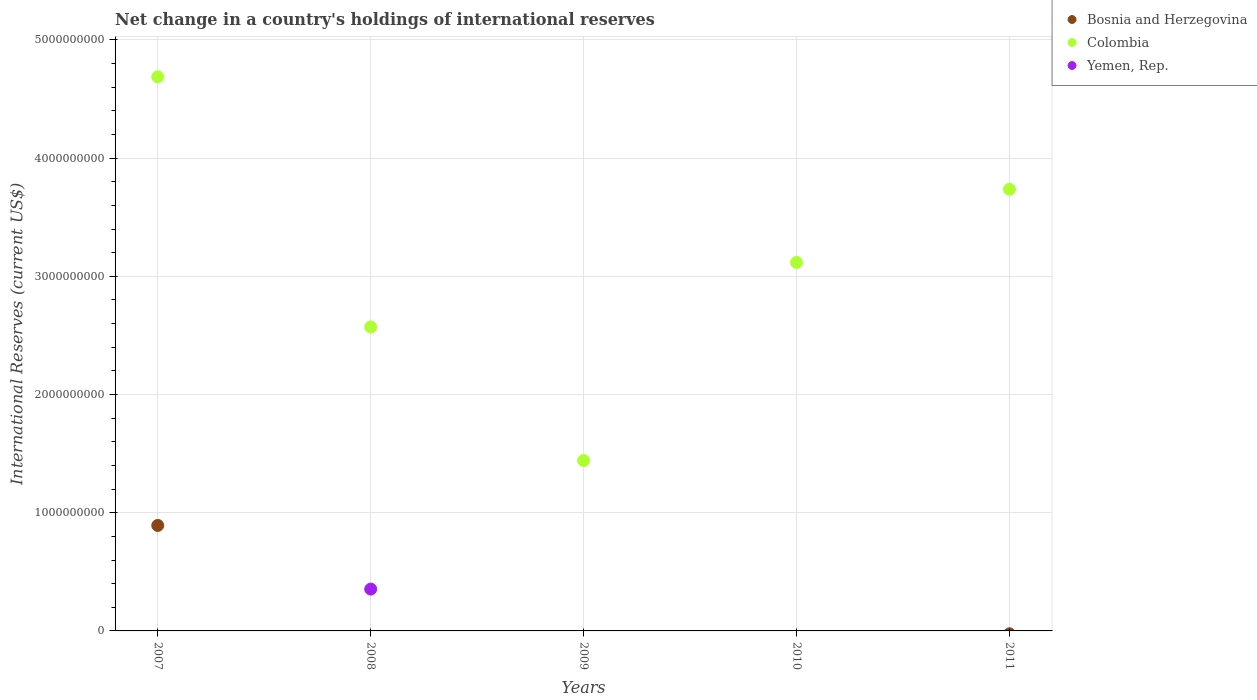What is the international reserves in Bosnia and Herzegovina in 2008?
Offer a terse response. 0. Across all years, what is the maximum international reserves in Yemen, Rep.?
Give a very brief answer. 3.54e+08. Across all years, what is the minimum international reserves in Colombia?
Provide a short and direct response. 1.44e+09. What is the total international reserves in Bosnia and Herzegovina in the graph?
Provide a short and direct response. 8.92e+08. What is the difference between the international reserves in Colombia in 2007 and that in 2011?
Your response must be concise. 9.51e+08. What is the average international reserves in Colombia per year?
Your answer should be compact. 3.11e+09. In the year 2007, what is the difference between the international reserves in Bosnia and Herzegovina and international reserves in Colombia?
Your answer should be very brief. -3.80e+09. What is the ratio of the international reserves in Colombia in 2009 to that in 2011?
Ensure brevity in your answer.  0.39. Is the international reserves in Colombia in 2007 less than that in 2011?
Provide a succinct answer. No. What is the difference between the highest and the second highest international reserves in Colombia?
Provide a short and direct response. 9.51e+08. What is the difference between the highest and the lowest international reserves in Colombia?
Your response must be concise. 3.25e+09. Is the international reserves in Yemen, Rep. strictly greater than the international reserves in Bosnia and Herzegovina over the years?
Make the answer very short. No. Is the international reserves in Bosnia and Herzegovina strictly less than the international reserves in Yemen, Rep. over the years?
Give a very brief answer. No. How many dotlines are there?
Offer a very short reply. 3. How many years are there in the graph?
Ensure brevity in your answer.  5. Are the values on the major ticks of Y-axis written in scientific E-notation?
Your answer should be very brief. No. Does the graph contain any zero values?
Offer a terse response. Yes. What is the title of the graph?
Provide a short and direct response. Net change in a country's holdings of international reserves. Does "Cabo Verde" appear as one of the legend labels in the graph?
Make the answer very short. No. What is the label or title of the Y-axis?
Ensure brevity in your answer.  International Reserves (current US$). What is the International Reserves (current US$) of Bosnia and Herzegovina in 2007?
Provide a succinct answer. 8.92e+08. What is the International Reserves (current US$) of Colombia in 2007?
Ensure brevity in your answer.  4.69e+09. What is the International Reserves (current US$) of Bosnia and Herzegovina in 2008?
Offer a very short reply. 0. What is the International Reserves (current US$) of Colombia in 2008?
Offer a terse response. 2.57e+09. What is the International Reserves (current US$) in Yemen, Rep. in 2008?
Your answer should be compact. 3.54e+08. What is the International Reserves (current US$) of Colombia in 2009?
Give a very brief answer. 1.44e+09. What is the International Reserves (current US$) of Bosnia and Herzegovina in 2010?
Make the answer very short. 0. What is the International Reserves (current US$) of Colombia in 2010?
Ensure brevity in your answer.  3.12e+09. What is the International Reserves (current US$) of Yemen, Rep. in 2010?
Make the answer very short. 0. What is the International Reserves (current US$) in Bosnia and Herzegovina in 2011?
Your answer should be very brief. 0. What is the International Reserves (current US$) of Colombia in 2011?
Your response must be concise. 3.74e+09. Across all years, what is the maximum International Reserves (current US$) in Bosnia and Herzegovina?
Your response must be concise. 8.92e+08. Across all years, what is the maximum International Reserves (current US$) of Colombia?
Your response must be concise. 4.69e+09. Across all years, what is the maximum International Reserves (current US$) of Yemen, Rep.?
Your answer should be compact. 3.54e+08. Across all years, what is the minimum International Reserves (current US$) in Colombia?
Your answer should be very brief. 1.44e+09. What is the total International Reserves (current US$) in Bosnia and Herzegovina in the graph?
Offer a terse response. 8.92e+08. What is the total International Reserves (current US$) in Colombia in the graph?
Keep it short and to the point. 1.56e+1. What is the total International Reserves (current US$) of Yemen, Rep. in the graph?
Offer a terse response. 3.54e+08. What is the difference between the International Reserves (current US$) in Colombia in 2007 and that in 2008?
Keep it short and to the point. 2.12e+09. What is the difference between the International Reserves (current US$) in Colombia in 2007 and that in 2009?
Provide a succinct answer. 3.25e+09. What is the difference between the International Reserves (current US$) of Colombia in 2007 and that in 2010?
Keep it short and to the point. 1.57e+09. What is the difference between the International Reserves (current US$) in Colombia in 2007 and that in 2011?
Offer a very short reply. 9.51e+08. What is the difference between the International Reserves (current US$) of Colombia in 2008 and that in 2009?
Provide a succinct answer. 1.13e+09. What is the difference between the International Reserves (current US$) in Colombia in 2008 and that in 2010?
Your answer should be very brief. -5.46e+08. What is the difference between the International Reserves (current US$) of Colombia in 2008 and that in 2011?
Your response must be concise. -1.17e+09. What is the difference between the International Reserves (current US$) in Colombia in 2009 and that in 2010?
Make the answer very short. -1.68e+09. What is the difference between the International Reserves (current US$) of Colombia in 2009 and that in 2011?
Make the answer very short. -2.30e+09. What is the difference between the International Reserves (current US$) in Colombia in 2010 and that in 2011?
Give a very brief answer. -6.19e+08. What is the difference between the International Reserves (current US$) in Bosnia and Herzegovina in 2007 and the International Reserves (current US$) in Colombia in 2008?
Your answer should be compact. -1.68e+09. What is the difference between the International Reserves (current US$) of Bosnia and Herzegovina in 2007 and the International Reserves (current US$) of Yemen, Rep. in 2008?
Make the answer very short. 5.38e+08. What is the difference between the International Reserves (current US$) of Colombia in 2007 and the International Reserves (current US$) of Yemen, Rep. in 2008?
Provide a succinct answer. 4.33e+09. What is the difference between the International Reserves (current US$) of Bosnia and Herzegovina in 2007 and the International Reserves (current US$) of Colombia in 2009?
Make the answer very short. -5.49e+08. What is the difference between the International Reserves (current US$) of Bosnia and Herzegovina in 2007 and the International Reserves (current US$) of Colombia in 2010?
Your answer should be very brief. -2.22e+09. What is the difference between the International Reserves (current US$) in Bosnia and Herzegovina in 2007 and the International Reserves (current US$) in Colombia in 2011?
Offer a very short reply. -2.84e+09. What is the average International Reserves (current US$) of Bosnia and Herzegovina per year?
Keep it short and to the point. 1.78e+08. What is the average International Reserves (current US$) of Colombia per year?
Offer a very short reply. 3.11e+09. What is the average International Reserves (current US$) in Yemen, Rep. per year?
Offer a terse response. 7.08e+07. In the year 2007, what is the difference between the International Reserves (current US$) of Bosnia and Herzegovina and International Reserves (current US$) of Colombia?
Your answer should be compact. -3.80e+09. In the year 2008, what is the difference between the International Reserves (current US$) in Colombia and International Reserves (current US$) in Yemen, Rep.?
Offer a terse response. 2.22e+09. What is the ratio of the International Reserves (current US$) in Colombia in 2007 to that in 2008?
Keep it short and to the point. 1.82. What is the ratio of the International Reserves (current US$) of Colombia in 2007 to that in 2009?
Give a very brief answer. 3.25. What is the ratio of the International Reserves (current US$) in Colombia in 2007 to that in 2010?
Provide a short and direct response. 1.5. What is the ratio of the International Reserves (current US$) of Colombia in 2007 to that in 2011?
Keep it short and to the point. 1.25. What is the ratio of the International Reserves (current US$) of Colombia in 2008 to that in 2009?
Your answer should be compact. 1.78. What is the ratio of the International Reserves (current US$) of Colombia in 2008 to that in 2010?
Provide a succinct answer. 0.82. What is the ratio of the International Reserves (current US$) of Colombia in 2008 to that in 2011?
Make the answer very short. 0.69. What is the ratio of the International Reserves (current US$) of Colombia in 2009 to that in 2010?
Your answer should be very brief. 0.46. What is the ratio of the International Reserves (current US$) of Colombia in 2009 to that in 2011?
Your answer should be compact. 0.39. What is the ratio of the International Reserves (current US$) of Colombia in 2010 to that in 2011?
Provide a short and direct response. 0.83. What is the difference between the highest and the second highest International Reserves (current US$) of Colombia?
Your response must be concise. 9.51e+08. What is the difference between the highest and the lowest International Reserves (current US$) of Bosnia and Herzegovina?
Provide a succinct answer. 8.92e+08. What is the difference between the highest and the lowest International Reserves (current US$) in Colombia?
Offer a very short reply. 3.25e+09. What is the difference between the highest and the lowest International Reserves (current US$) in Yemen, Rep.?
Provide a short and direct response. 3.54e+08. 